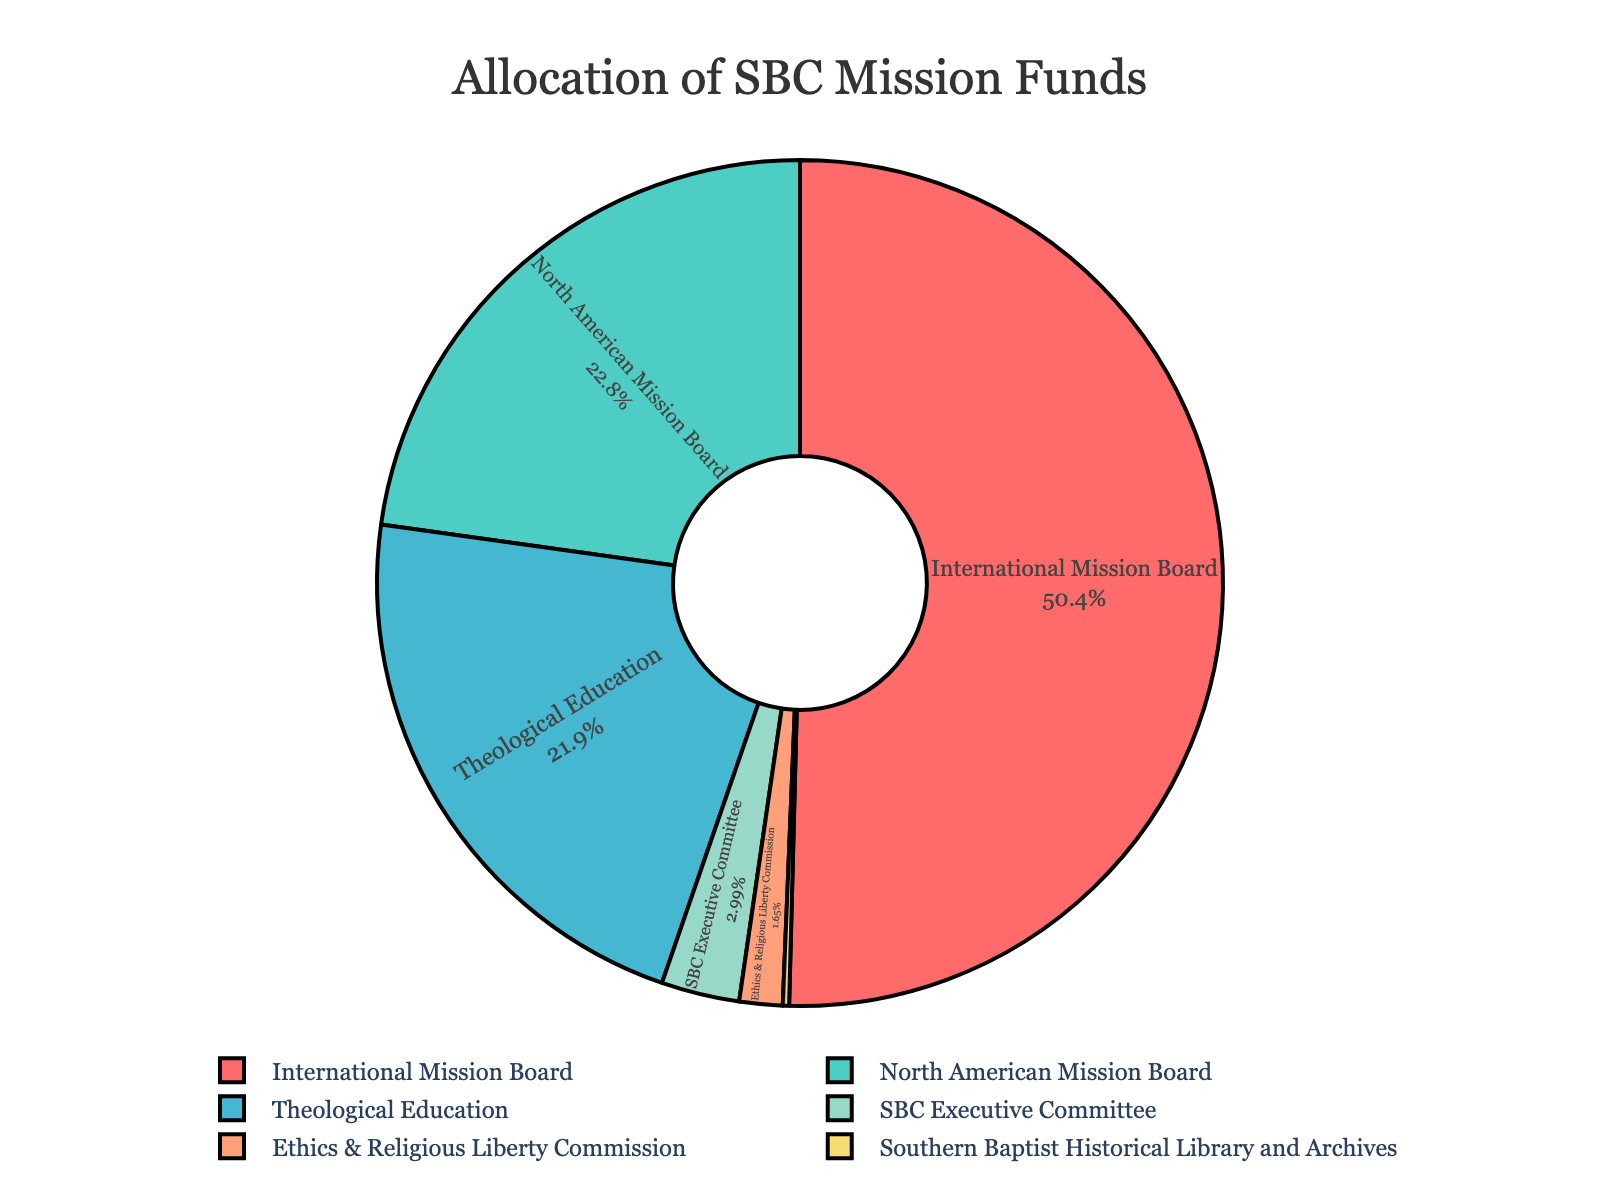What is the percentage allocation for the International Mission Board? The International Mission Board has a stated allocation of 50.41% in the pie chart, indicating how much of the funds are being given to this ministry.
Answer: 50.41% Which ministry receives the second largest percentage of the mission funds? By looking at the different sections of the pie chart and comparing their sizes, the North American Mission Board is identified as receiving the second largest allocation.
Answer: North American Mission Board How much more percentage is allocated to the International Mission Board compared to the Southern Baptist Historical Library and Archives? First, identify the percentage for both ministries: International Mission Board (50.41%) and Southern Baptist Historical Library and Archives (0.24%). Then subtract the smaller percentage from the larger one: 50.41% - 0.24% = 50.17%.
Answer: 50.17% What is the combined percentage of funds allocated to the Theological Education and the Ethics & Religious Liberty Commission? Add the given percentages for Theological Education (21.92%) and Ethics & Religious Liberty Commission (1.65%): 21.92% + 1.65% = 23.57%.
Answer: 23.57% Which ministry has the smallest allocation and what is that percentage? From examining the pie chart, the Southern Baptist Historical Library and Archives has the smallest allocation, which is 0.24%.
Answer: Southern Baptist Historical Library and Archives, 0.24% Compare the allocation percentage of the North American Mission Board with the Theological Education. Which one has a higher percentage and by how much? Compare the allocations: North American Mission Board (22.79%) and Theological Education (21.92%). North American Mission Board has a higher percentage. Subtract the smaller percentage from the larger one: 22.79% - 21.92% = 0.87%.
Answer: North American Mission Board, 0.87% What is the average percentage allocation of funds for all the ministries combined? First, sum the percentages of all ministries: 50.41 + 22.79 + 21.92 + 1.65 + 2.99 + 0.24 = 100%. Then divide by the number of ministries (6): 100 / 6 ≈ 16.67%.
Answer: 16.67% Identify the ministry associated with the color red in the pie chart. By examining the colors used in the chart and matching them with their corresponding labels, the red section is identified as representing the International Mission Board.
Answer: International Mission Board 